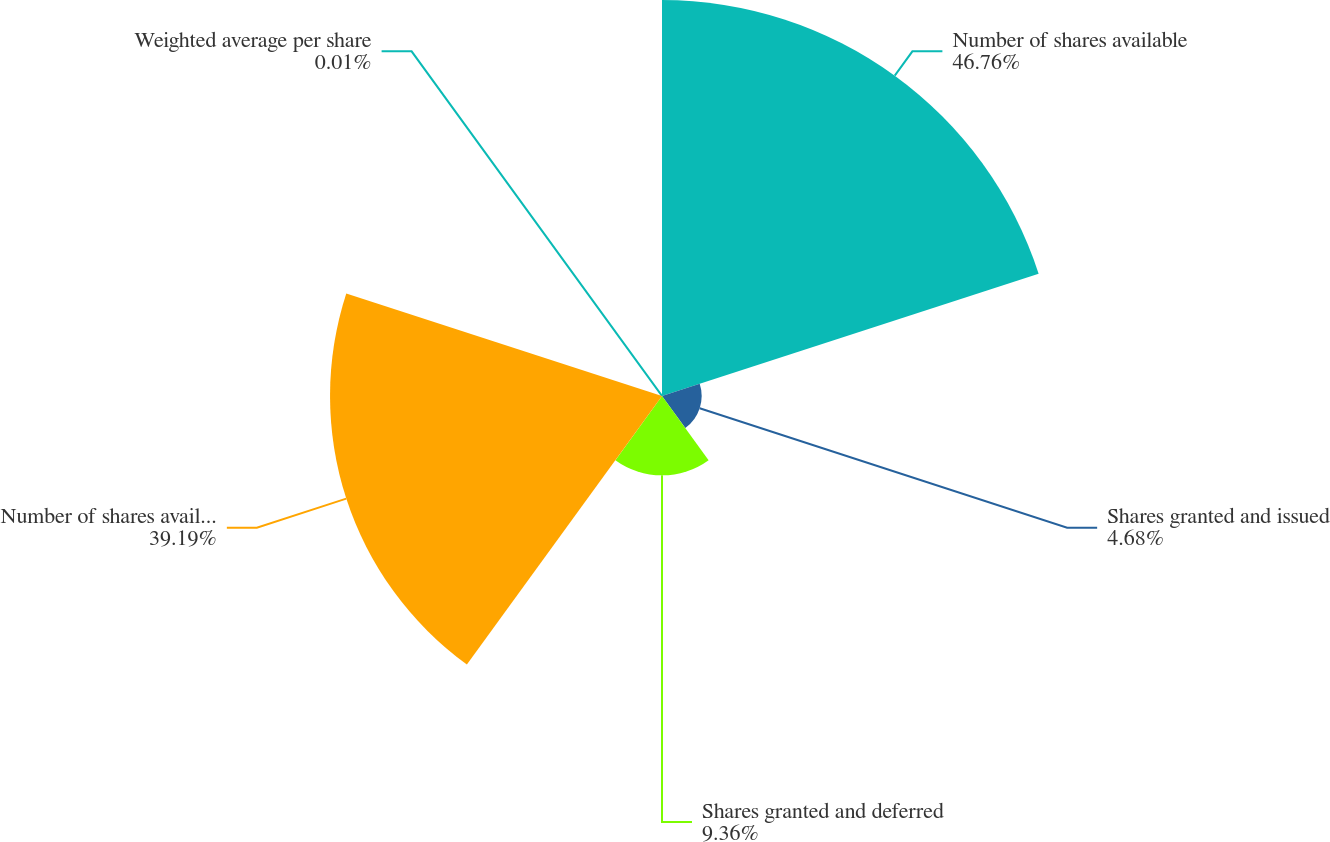Convert chart. <chart><loc_0><loc_0><loc_500><loc_500><pie_chart><fcel>Number of shares available<fcel>Shares granted and issued<fcel>Shares granted and deferred<fcel>Number of shares available end<fcel>Weighted average per share<nl><fcel>46.75%<fcel>4.68%<fcel>9.36%<fcel>39.19%<fcel>0.01%<nl></chart> 